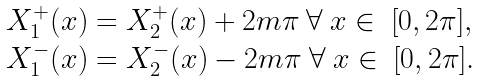Convert formula to latex. <formula><loc_0><loc_0><loc_500><loc_500>\begin{array} { l l l } X _ { 1 } ^ { + } ( x ) = X _ { 2 } ^ { + } ( x ) + 2 m \pi \ \forall \ x \in \ [ 0 , 2 \pi ] , \\ X _ { 1 } ^ { - } ( x ) = X _ { 2 } ^ { - } ( x ) - 2 m \pi \ \forall \ x \in \ [ 0 , 2 \pi ] . \\ \end{array}</formula> 